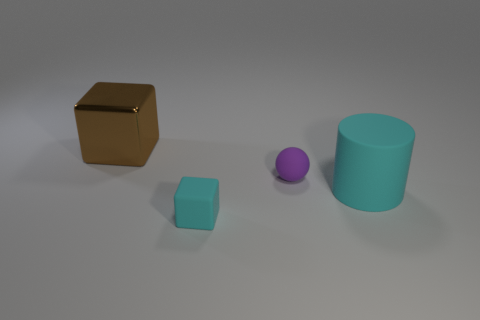Add 3 gray cylinders. How many objects exist? 7 Subtract 1 blocks. How many blocks are left? 1 Subtract 1 cyan blocks. How many objects are left? 3 Subtract all blue balls. Subtract all blue blocks. How many balls are left? 1 Subtract all blue balls. How many purple cubes are left? 0 Subtract all brown shiny things. Subtract all small purple objects. How many objects are left? 2 Add 1 rubber things. How many rubber things are left? 4 Add 2 large brown objects. How many large brown objects exist? 3 